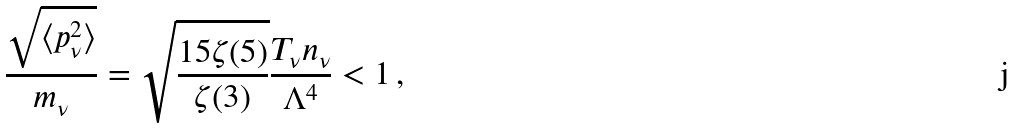<formula> <loc_0><loc_0><loc_500><loc_500>\frac { \sqrt { \langle p _ { \nu } ^ { 2 } \rangle } } { m _ { \nu } } = \sqrt { \frac { 1 5 \zeta ( 5 ) } { \zeta ( 3 ) } } \frac { T _ { \nu } n _ { \nu } } { \Lambda ^ { 4 } } < 1 \, ,</formula> 